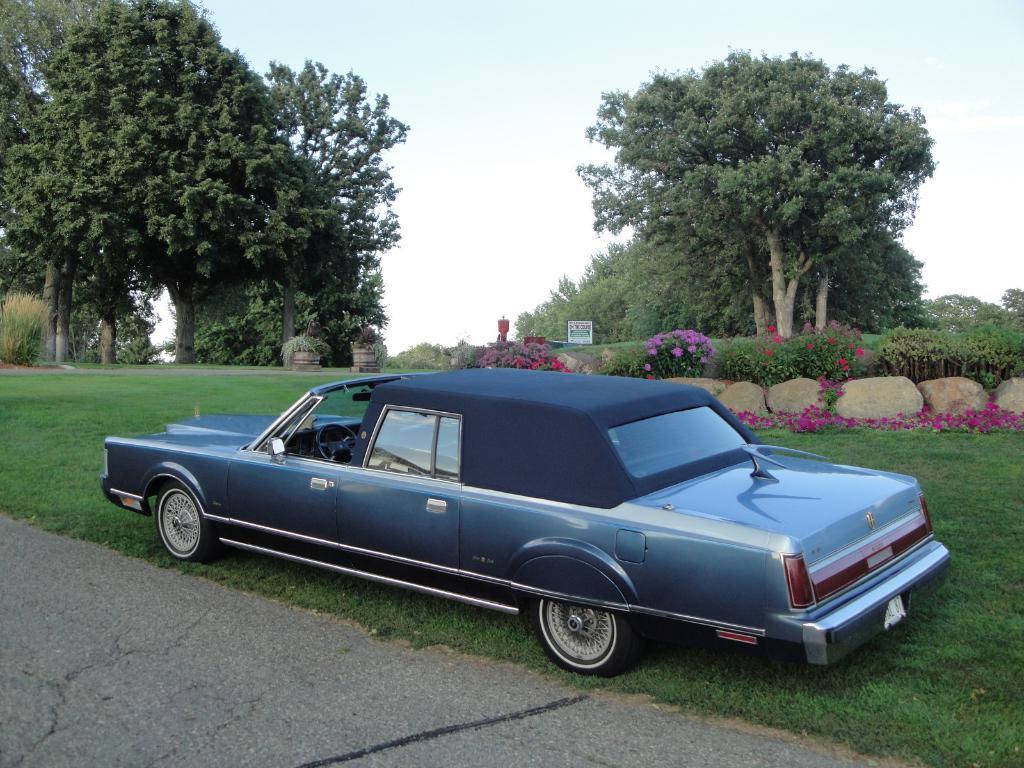In one or two sentences, can you explain what this image depicts? In the foreground of the picture there are pavement, grass and a car. In the center of the picture there are trees, plants, grass and flowers. Sky is little bit cloudy. 